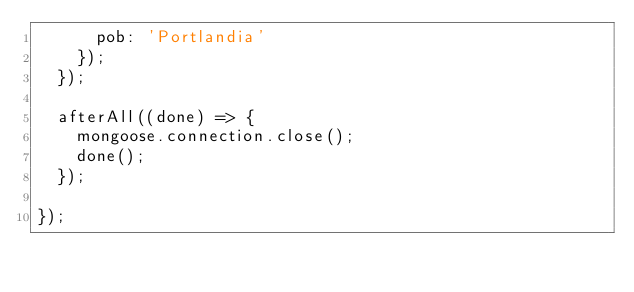Convert code to text. <code><loc_0><loc_0><loc_500><loc_500><_JavaScript_>      pob: 'Portlandia'
    });
  });

  afterAll((done) => {
    mongoose.connection.close();
    done();
  }); 

});
</code> 